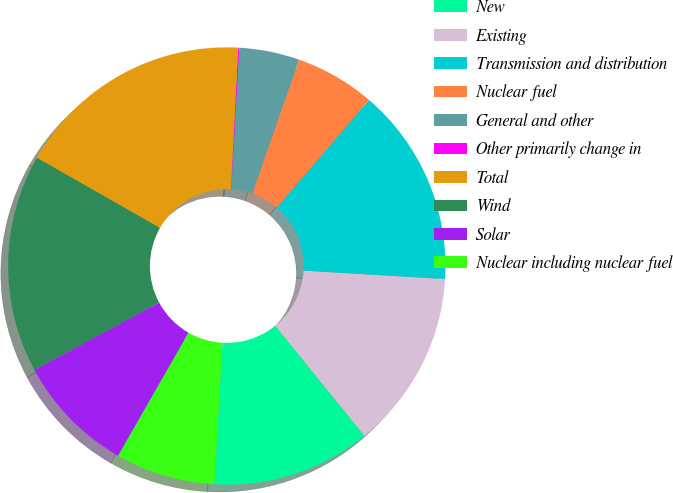Convert chart. <chart><loc_0><loc_0><loc_500><loc_500><pie_chart><fcel>New<fcel>Existing<fcel>Transmission and distribution<fcel>Nuclear fuel<fcel>General and other<fcel>Other primarily change in<fcel>Total<fcel>Wind<fcel>Solar<fcel>Nuclear including nuclear fuel<nl><fcel>11.75%<fcel>13.21%<fcel>14.67%<fcel>5.91%<fcel>4.45%<fcel>0.08%<fcel>17.59%<fcel>16.13%<fcel>8.83%<fcel>7.37%<nl></chart> 